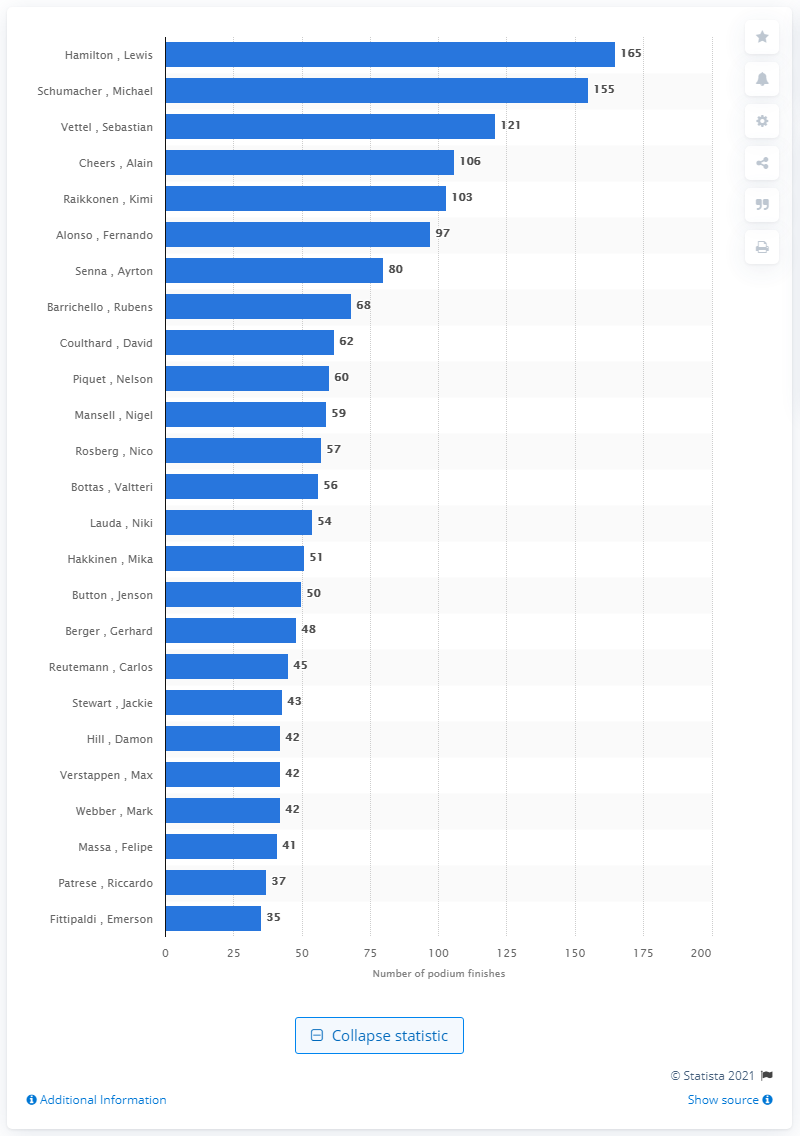Indicate a few pertinent items in this graphic. During his career, Lewis Hamilton achieved 165 podium finishes, which is a remarkable accomplishment in the world of Formula One racing. 